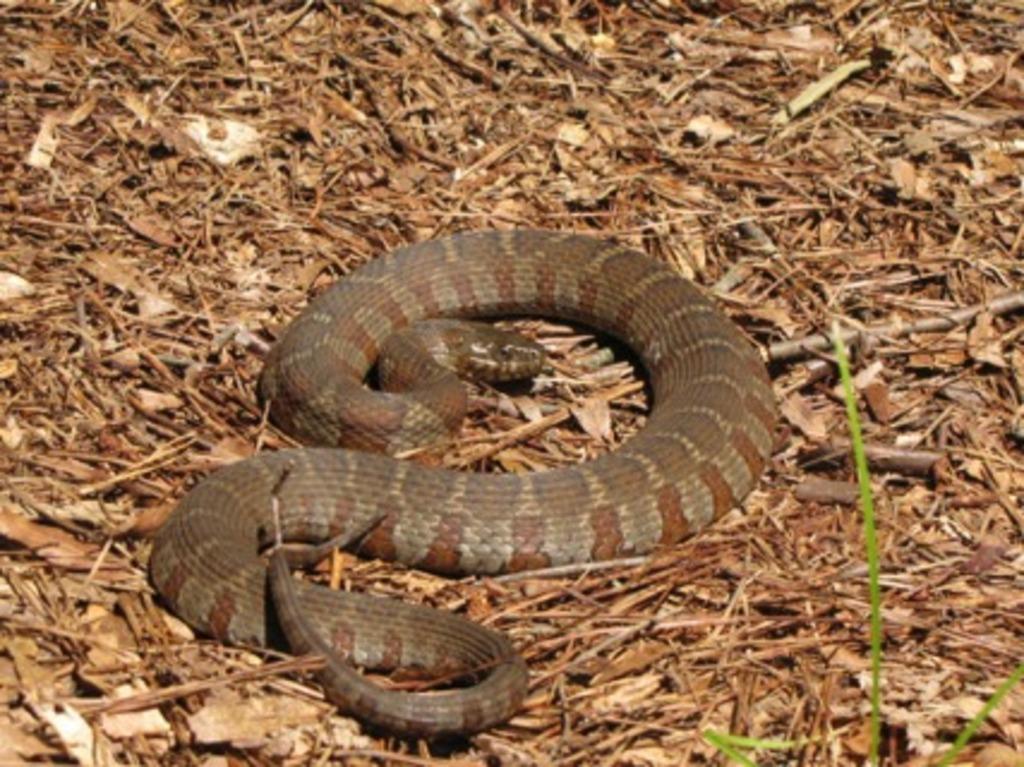Describe this image in one or two sentences. In this image we can see a snake and some dried leaves on the ground. 